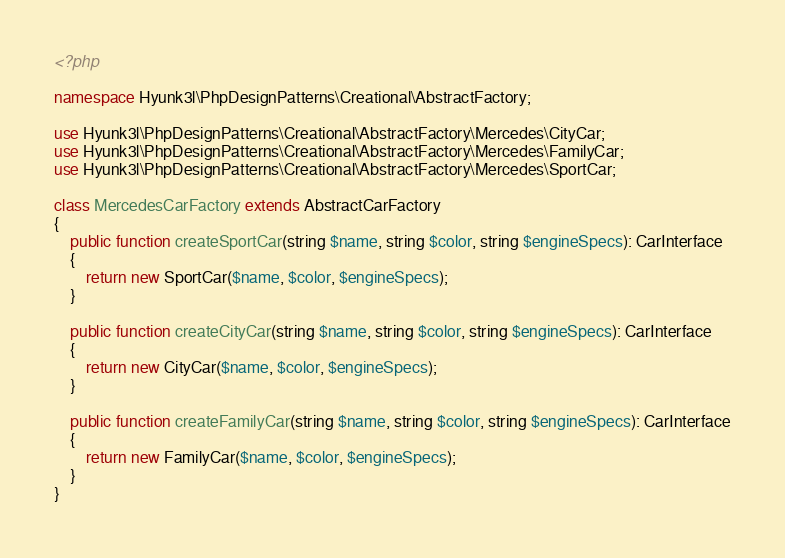<code> <loc_0><loc_0><loc_500><loc_500><_PHP_><?php

namespace Hyunk3l\PhpDesignPatterns\Creational\AbstractFactory;

use Hyunk3l\PhpDesignPatterns\Creational\AbstractFactory\Mercedes\CityCar;
use Hyunk3l\PhpDesignPatterns\Creational\AbstractFactory\Mercedes\FamilyCar;
use Hyunk3l\PhpDesignPatterns\Creational\AbstractFactory\Mercedes\SportCar;

class MercedesCarFactory extends AbstractCarFactory
{
    public function createSportCar(string $name, string $color, string $engineSpecs): CarInterface
    {
        return new SportCar($name, $color, $engineSpecs);
    }

    public function createCityCar(string $name, string $color, string $engineSpecs): CarInterface
    {
        return new CityCar($name, $color, $engineSpecs);
    }

    public function createFamilyCar(string $name, string $color, string $engineSpecs): CarInterface
    {
        return new FamilyCar($name, $color, $engineSpecs);
    }
}
</code> 